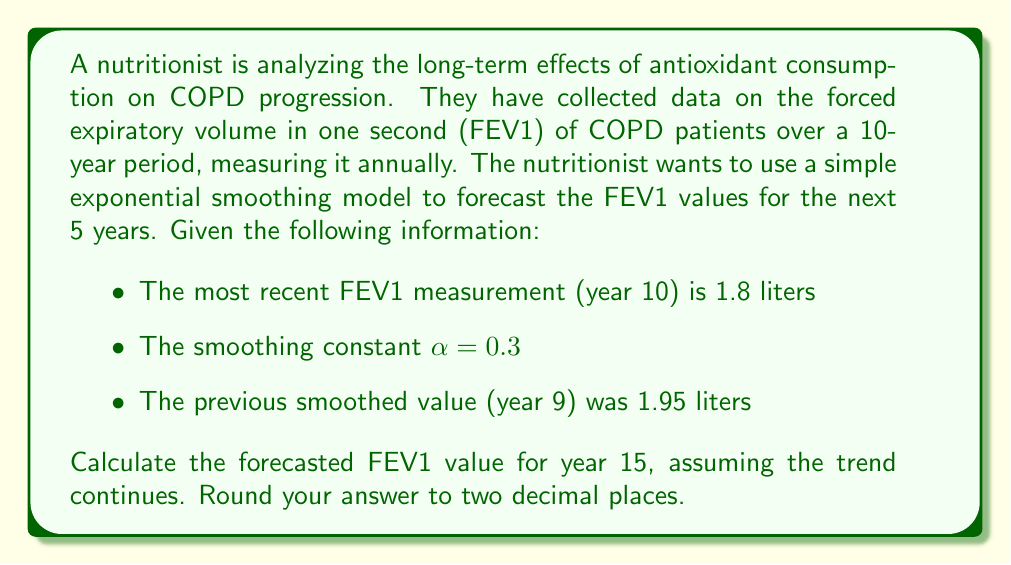Provide a solution to this math problem. To solve this problem, we'll use the simple exponential smoothing model. This model is appropriate for time series data without clear trends or seasonality, which is often the case with long-term health metrics like FEV1 in COPD patients.

The formula for simple exponential smoothing is:

$$F_{t+1} = \alpha Y_t + (1-\alpha)F_t$$

Where:
$F_{t+1}$ is the forecast for the next period
$\alpha$ is the smoothing constant
$Y_t$ is the actual value at time t
$F_t$ is the forecasted value for time t

Let's calculate the smoothed value for year 10:

$$F_{11} = \alpha Y_{10} + (1-\alpha)F_{10}$$
$$F_{11} = 0.3 \times 1.8 + (1-0.3) \times 1.95$$
$$F_{11} = 0.54 + 1.365 = 1.905$$

Now, since we don't have actual values for future years, we assume the forecast remains constant for all future periods in simple exponential smoothing. Therefore:

$$F_{12} = F_{13} = F_{14} = F_{15} = 1.905$$

The forecasted FEV1 value for year 15 is 1.905 liters, which rounds to 1.91 liters when we round to two decimal places.
Answer: 1.91 liters 